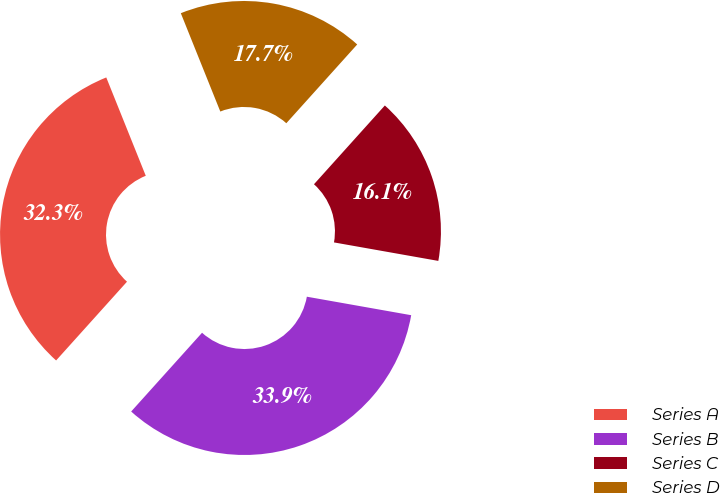<chart> <loc_0><loc_0><loc_500><loc_500><pie_chart><fcel>Series A<fcel>Series B<fcel>Series C<fcel>Series D<nl><fcel>32.26%<fcel>33.87%<fcel>16.13%<fcel>17.74%<nl></chart> 